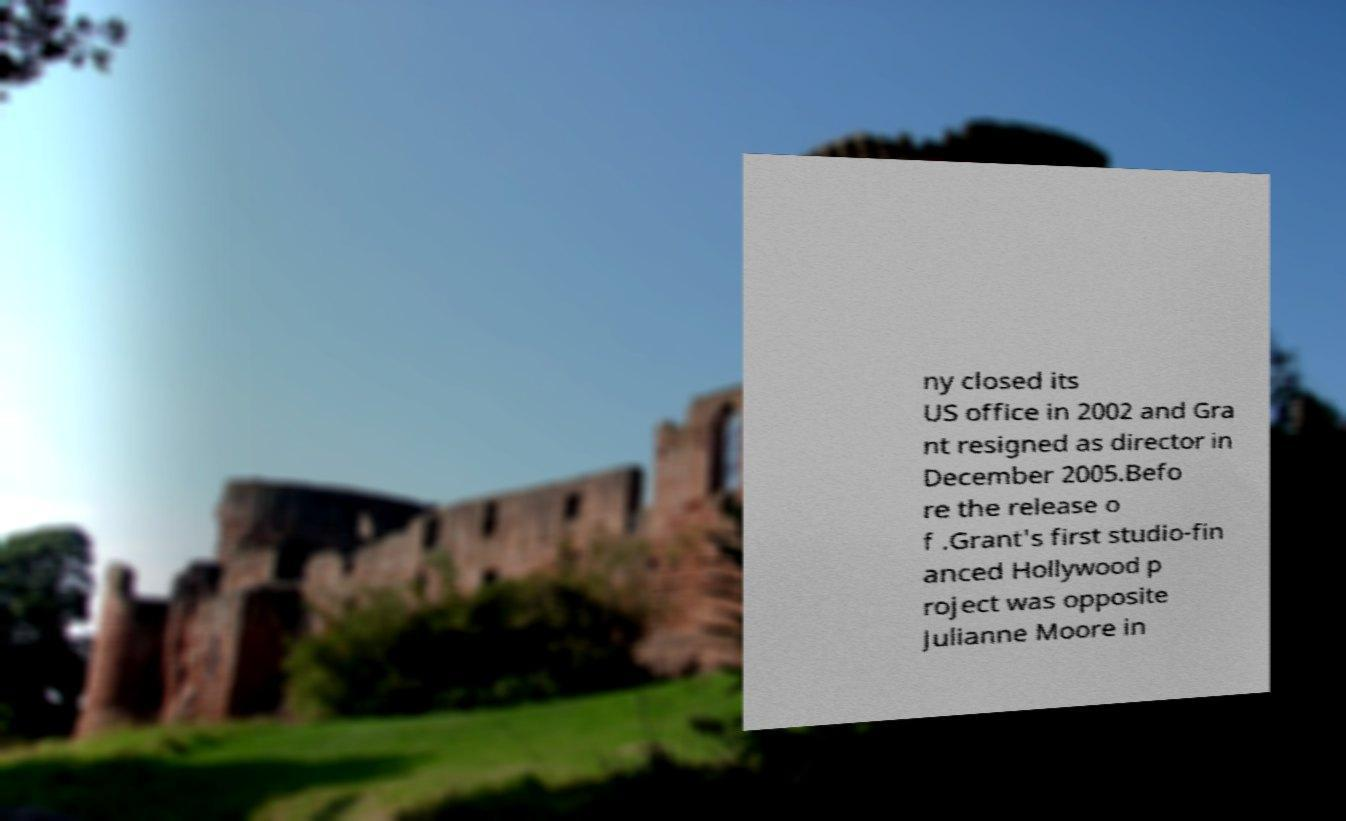Please read and relay the text visible in this image. What does it say? ny closed its US office in 2002 and Gra nt resigned as director in December 2005.Befo re the release o f .Grant's first studio-fin anced Hollywood p roject was opposite Julianne Moore in 